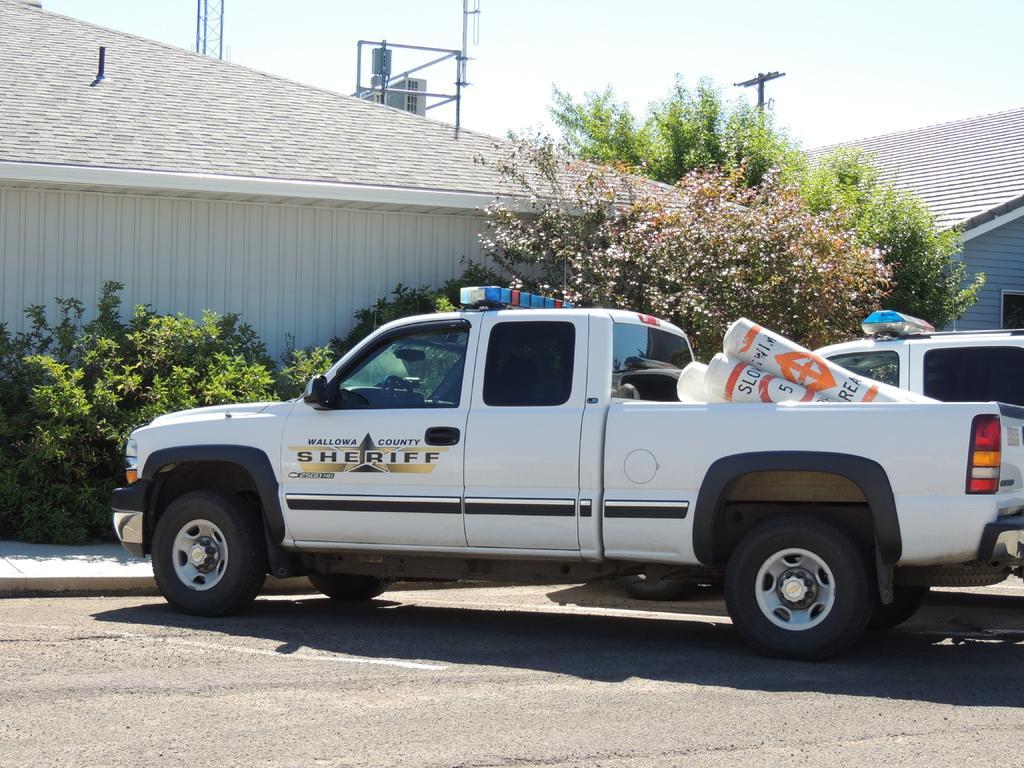Could you give a brief overview of what you see in this image? In the center of the image we can see two vehicles on the road. And in the front vehicle, we can see some objects. and we can see some text on the vehicle. In the background, we can see the sky, clouds, buildings, trees, one window, road and a few other objects. 